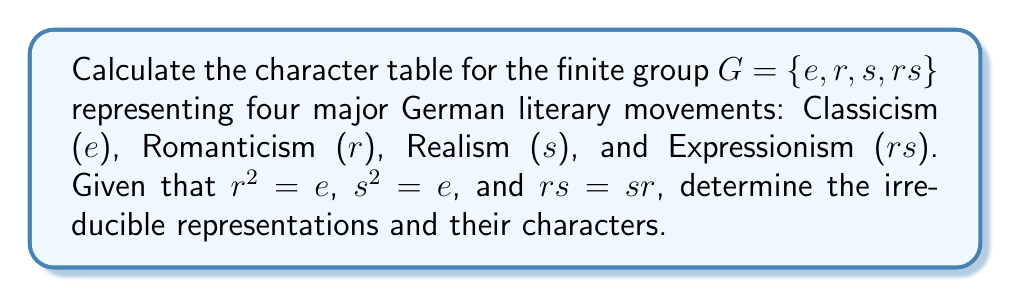Could you help me with this problem? 1. First, identify the conjugacy classes of $G$:
   Since $G$ is abelian, each element forms its own conjugacy class.
   $C_1 = \{e\}$, $C_2 = \{r\}$, $C_3 = \{s\}$, $C_4 = \{rs\}$

2. The number of irreducible representations equals the number of conjugacy classes, so there are 4 irreducible representations.

3. For an abelian group, all irreducible representations are 1-dimensional.

4. Construct the character table:
   - The trivial representation $\chi_1$ assigns 1 to all elements.
   - For $\chi_2$, assign 1 to $e$ and $r$, and -1 to $s$ and $rs$.
   - For $\chi_3$, assign 1 to $e$ and $s$, and -1 to $r$ and $rs$.
   - For $\chi_4$, assign 1 to $e$ and -1 to $r$, $s$, and $rs$.

5. The character table:

   $$\begin{array}{c|cccc}
      & e & r & s & rs \\
   \hline
   \chi_1 & 1 & 1 & 1 & 1 \\
   \chi_2 & 1 & 1 & -1 & -1 \\
   \chi_3 & 1 & -1 & 1 & -1 \\
   \chi_4 & 1 & -1 & -1 & 1
   \end{array}$$

6. Verify orthogonality relations:
   - Column orthogonality: $\sum_i \chi_i(g)\overline{\chi_i(h)} = |G|\delta_{gh}$
   - Row orthogonality: $\sum_g \chi_i(g)\overline{\chi_j(g)} = |G|\delta_{ij}$

Both conditions are satisfied, confirming the correctness of the character table.
Answer: $$\begin{array}{c|cccc}
   & e & r & s & rs \\
\hline
\chi_1 & 1 & 1 & 1 & 1 \\
\chi_2 & 1 & 1 & -1 & -1 \\
\chi_3 & 1 & -1 & 1 & -1 \\
\chi_4 & 1 & -1 & -1 & 1
\end{array}$$ 